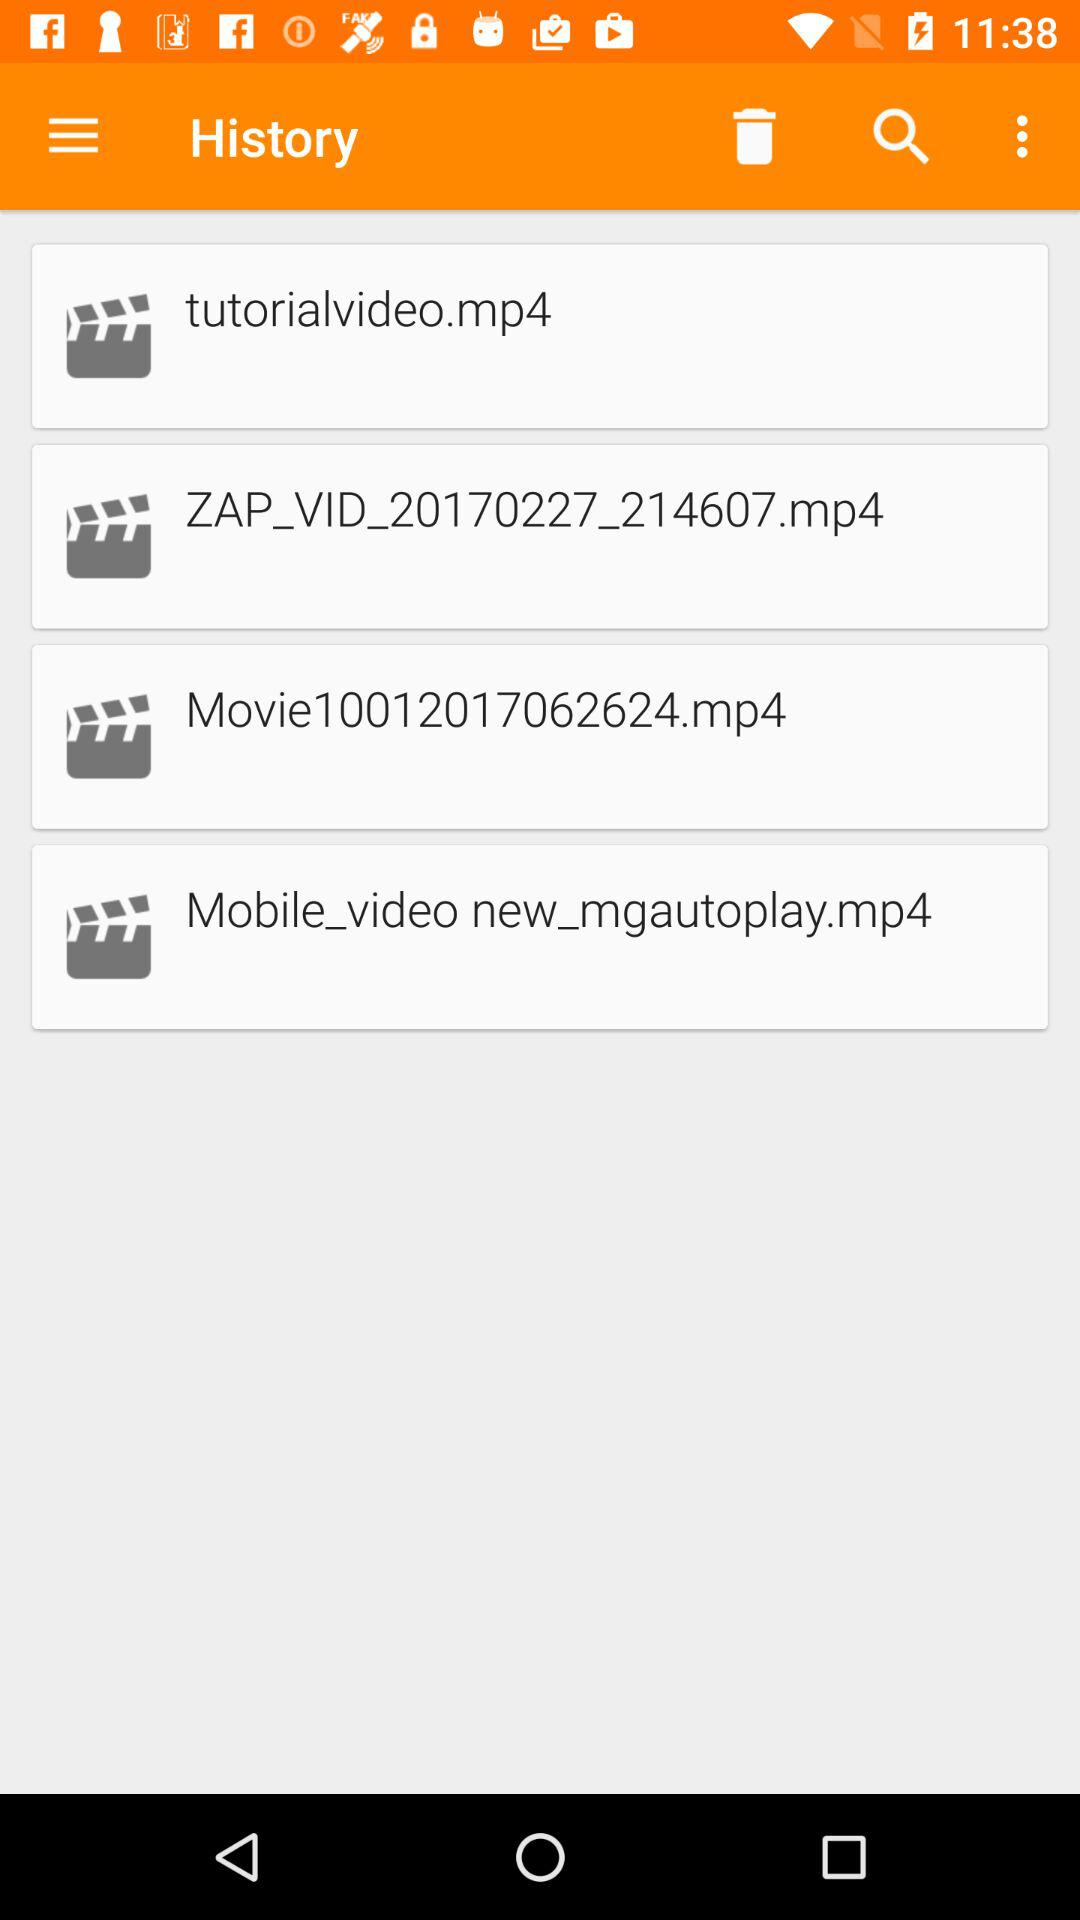How many video files are there in the history?
Answer the question using a single word or phrase. 4 